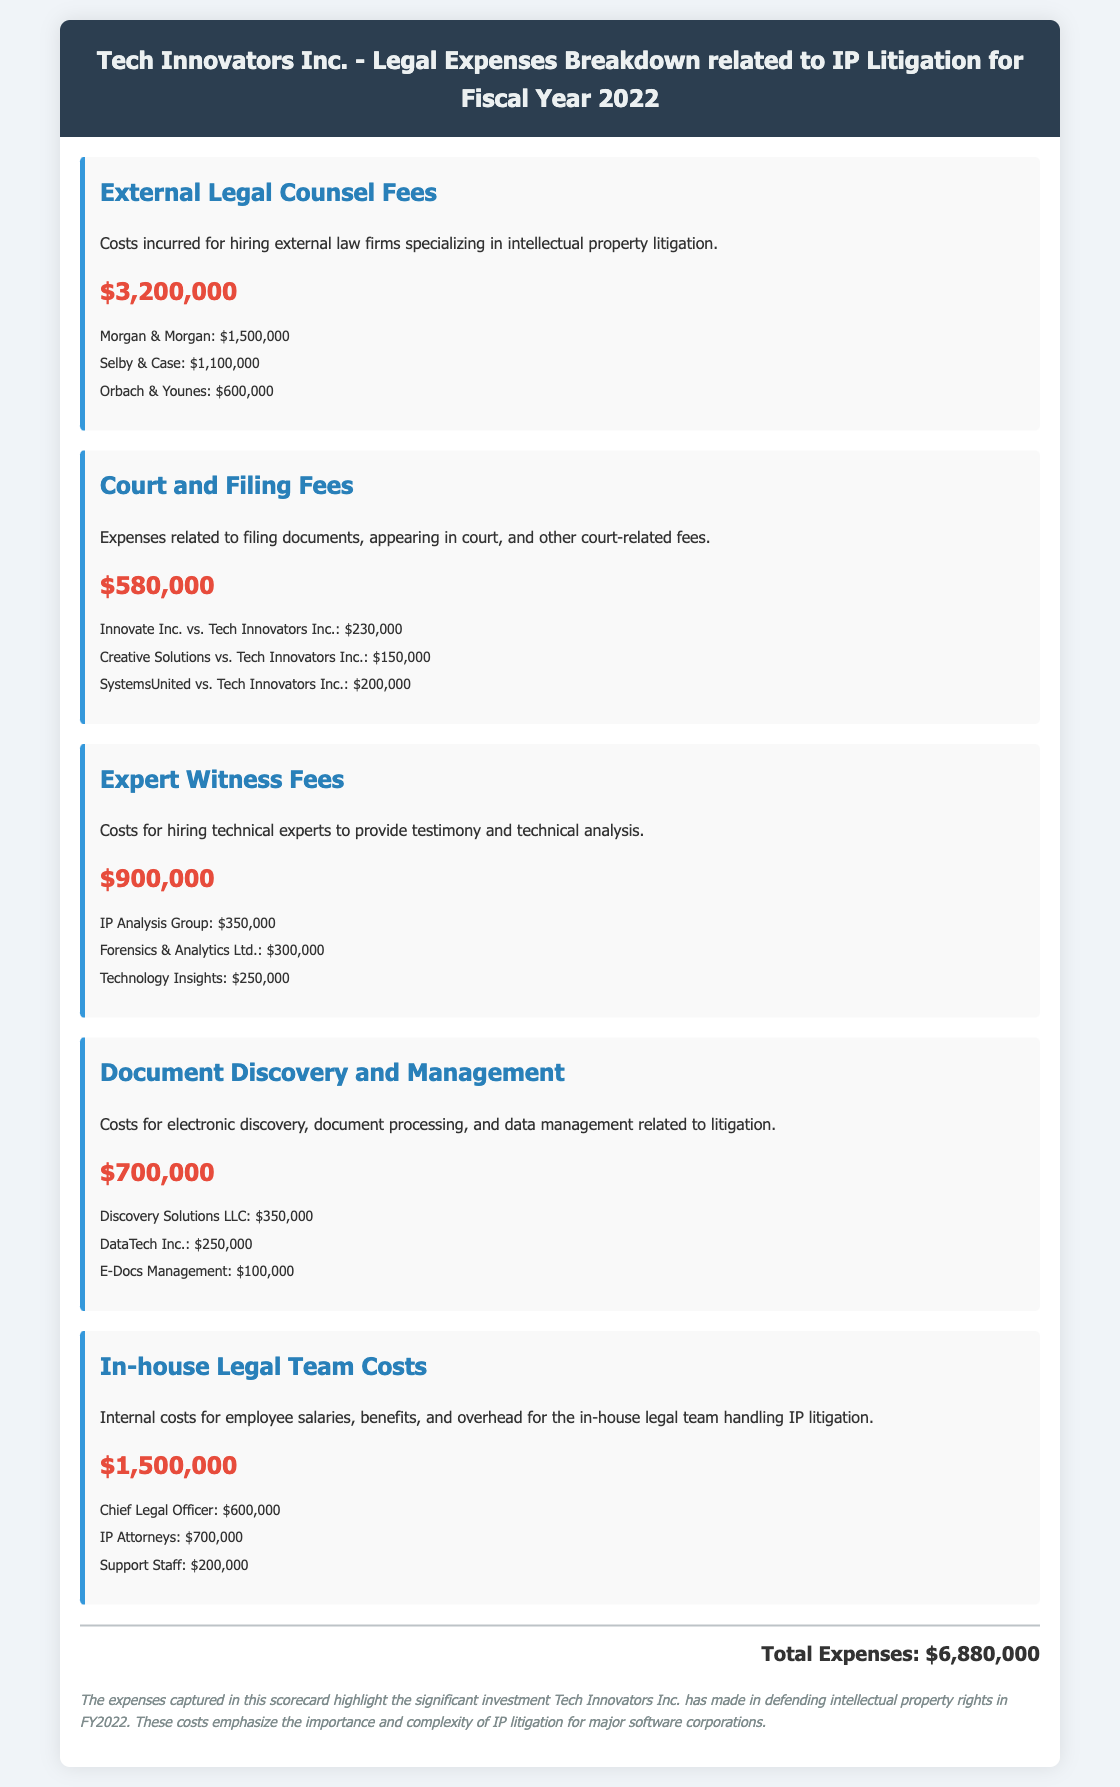What are the external legal counsel fees? The document states the external legal counsel fees are $3,200,000.
Answer: $3,200,000 How much was spent on expert witness fees? The expert witness fees listed in the document amount to $900,000.
Answer: $900,000 Who received the highest payment for external legal counsel? According to the details, Morgan & Morgan received the highest payment of $1,500,000.
Answer: Morgan & Morgan What is the total amount spent on court and filing fees? The total for court and filing fees, as per the document, is $580,000.
Answer: $580,000 How many categories of expenses are listed? The document lists five distinct categories of expenses related to IP litigation.
Answer: Five What is the largest single expense category? The largest single expense category is external legal counsel fees totaling $3,200,000.
Answer: External Legal Counsel Fees Which category includes costs for electronic discovery? The document specifies that Document Discovery and Management includes costs for electronic discovery.
Answer: Document Discovery and Management How much did the in-house legal team cost? The in-house legal team costs total $1,500,000, as mentioned in the document.
Answer: $1,500,000 What is the total legal expense for Fiscal Year 2022? The total legal expenses for fiscal year 2022 are calculated as $6,880,000.
Answer: $6,880,000 